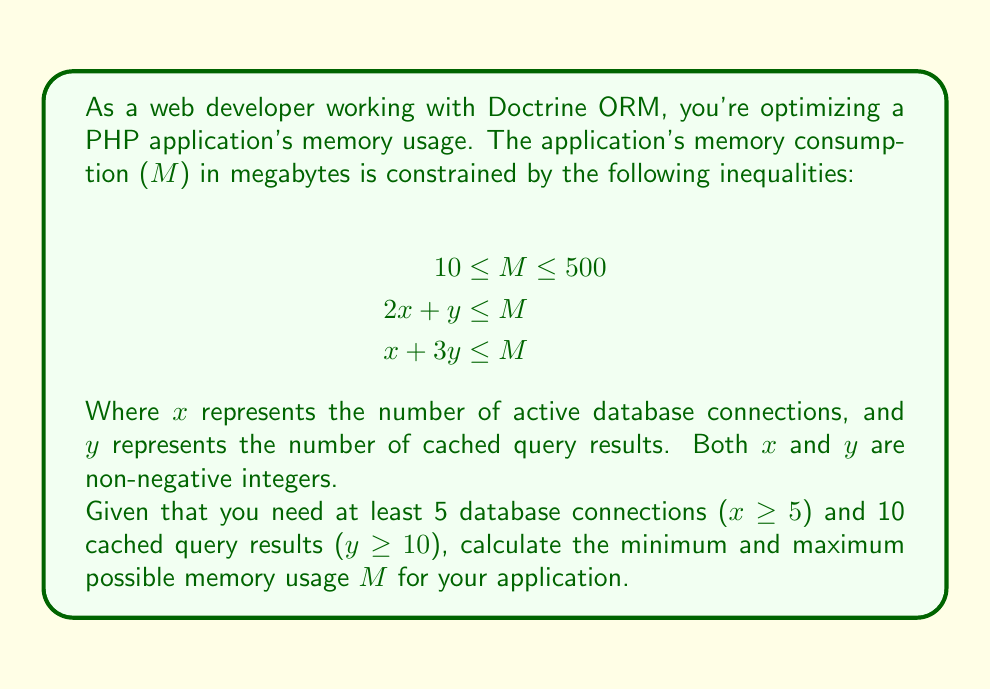What is the answer to this math problem? Let's approach this step-by-step:

1) First, we need to consider the given constraints:
   - $10 \leq M \leq 500$
   - $2x + y \leq M$
   - $x + 3y \leq M$
   - $x \geq 5$
   - $y \geq 10$

2) To find the minimum M, we need to satisfy all constraints with the smallest possible M:

   a) Start with minimum values: $x = 5$ and $y = 10$
   
   b) Check the inequalities:
      - $2x + y = 2(5) + 10 = 20$
      - $x + 3y = 5 + 3(10) = 35$
   
   c) M must be greater than or equal to both of these values and also ≥ 10.
      So, minimum $M = \max(20, 35, 10) = 35$

3) To find the maximum M, we simply use the upper bound given in the first inequality:
   Maximum $M = 500$

4) Verify that these values satisfy all constraints:
   - $35 \leq M \leq 500$ (satisfies the first inequality)
   - For min M (35): $20 \leq 35$ and $35 \leq 35$ (satisfies second and third inequalities)
   - For max M (500): Any valid x and y will satisfy the inequalities as 500 is much larger.
   - $x \geq 5$ and $y \geq 10$ are satisfied in our calculation.
Answer: Minimum memory usage: 35 MB
Maximum memory usage: 500 MB 